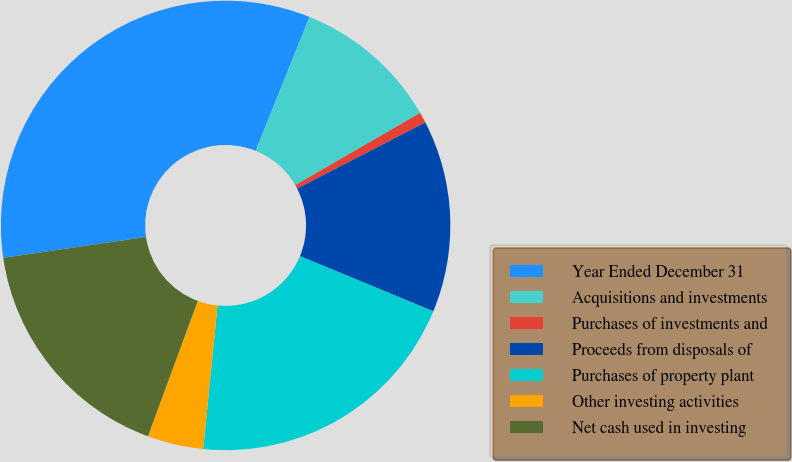Convert chart to OTSL. <chart><loc_0><loc_0><loc_500><loc_500><pie_chart><fcel>Year Ended December 31<fcel>Acquisitions and investments<fcel>Purchases of investments and<fcel>Proceeds from disposals of<fcel>Purchases of property plant<fcel>Other investing activities<fcel>Net cash used in investing<nl><fcel>33.4%<fcel>10.56%<fcel>0.77%<fcel>13.82%<fcel>20.35%<fcel>4.03%<fcel>17.08%<nl></chart> 